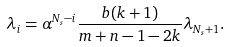<formula> <loc_0><loc_0><loc_500><loc_500>\lambda _ { i } = \alpha ^ { N _ { s } - i } \frac { b ( k + 1 ) } { m + n - 1 - 2 k } \lambda _ { N _ { s } + 1 } .</formula> 